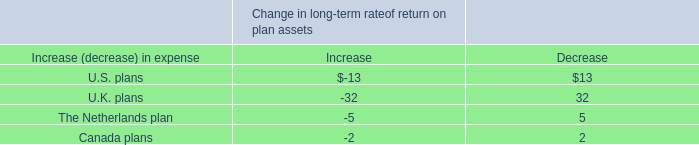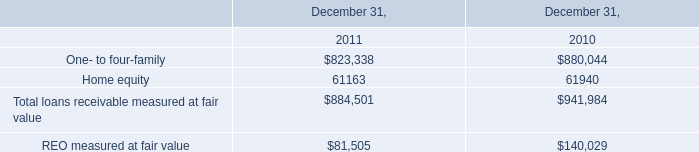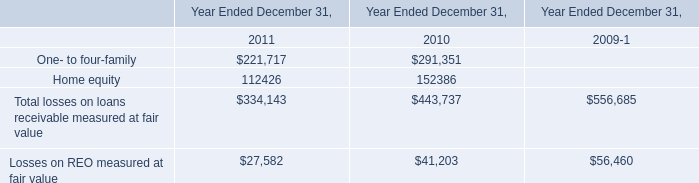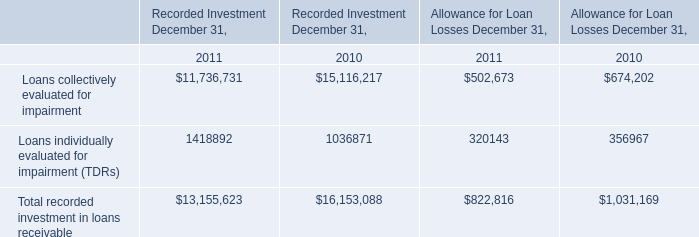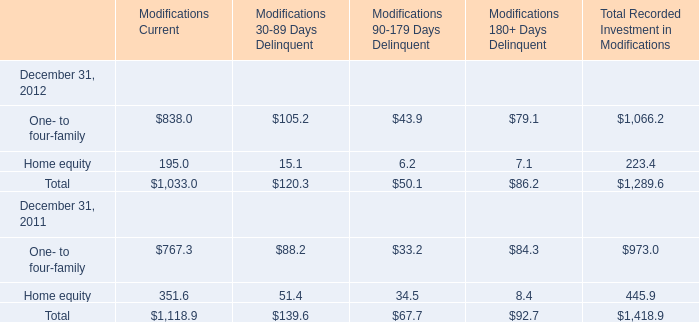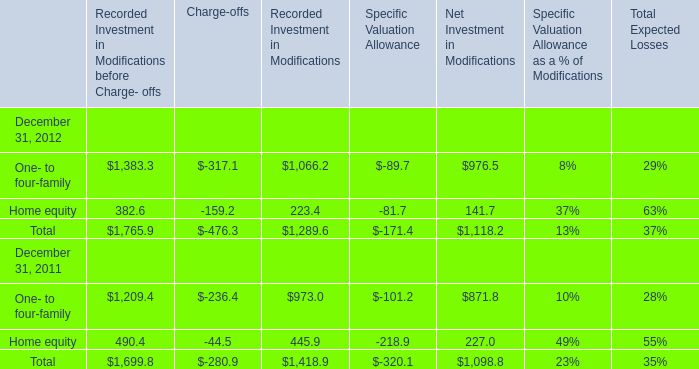What will One- to four-family be like in 2013 if it develops with the same increasing rate as current? 
Computations: ((1 + ((((((1383.3 + -317.1) + 1066.2) + -89.7) + 976.5) - ((((1209.4 + -236.4) + 973) + -101.2) + 871.8)) / ((((1209.4 + -236.4) + 973) + -101.2) + 871.8))) * ((((1383.3 + -317.1) + 1066.2) + -89.7) + 976.5))
Answer: 3355.50638. 